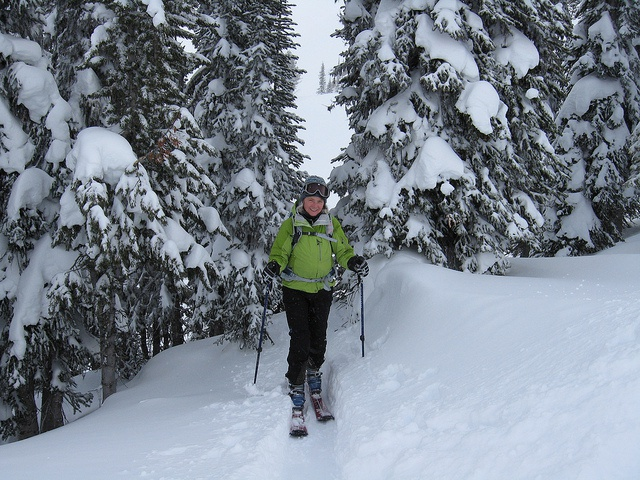Describe the objects in this image and their specific colors. I can see people in black, gray, darkgreen, and darkgray tones and skis in black and gray tones in this image. 